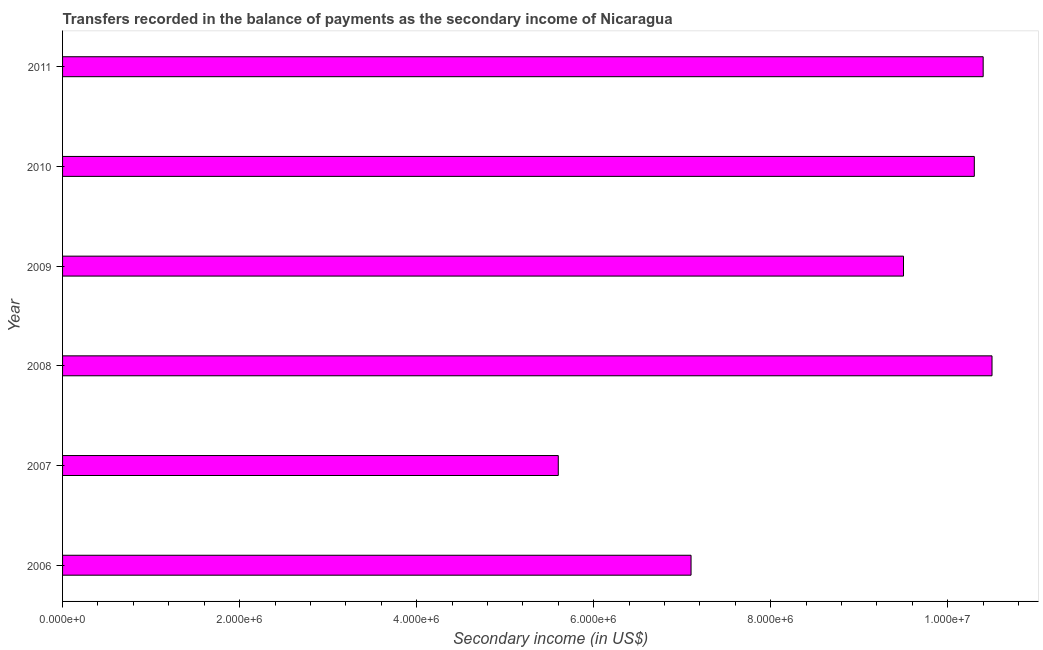Does the graph contain any zero values?
Ensure brevity in your answer.  No. Does the graph contain grids?
Provide a succinct answer. No. What is the title of the graph?
Offer a terse response. Transfers recorded in the balance of payments as the secondary income of Nicaragua. What is the label or title of the X-axis?
Offer a terse response. Secondary income (in US$). What is the label or title of the Y-axis?
Give a very brief answer. Year. What is the amount of secondary income in 2008?
Your response must be concise. 1.05e+07. Across all years, what is the maximum amount of secondary income?
Make the answer very short. 1.05e+07. Across all years, what is the minimum amount of secondary income?
Provide a short and direct response. 5.60e+06. In which year was the amount of secondary income maximum?
Keep it short and to the point. 2008. In which year was the amount of secondary income minimum?
Provide a short and direct response. 2007. What is the sum of the amount of secondary income?
Your response must be concise. 5.34e+07. What is the difference between the amount of secondary income in 2009 and 2011?
Give a very brief answer. -9.00e+05. What is the average amount of secondary income per year?
Offer a very short reply. 8.90e+06. What is the median amount of secondary income?
Give a very brief answer. 9.90e+06. What is the ratio of the amount of secondary income in 2008 to that in 2011?
Offer a very short reply. 1.01. What is the difference between the highest and the second highest amount of secondary income?
Keep it short and to the point. 1.00e+05. Is the sum of the amount of secondary income in 2007 and 2010 greater than the maximum amount of secondary income across all years?
Provide a short and direct response. Yes. What is the difference between the highest and the lowest amount of secondary income?
Your answer should be compact. 4.90e+06. In how many years, is the amount of secondary income greater than the average amount of secondary income taken over all years?
Provide a succinct answer. 4. What is the difference between two consecutive major ticks on the X-axis?
Provide a succinct answer. 2.00e+06. What is the Secondary income (in US$) in 2006?
Ensure brevity in your answer.  7.10e+06. What is the Secondary income (in US$) in 2007?
Make the answer very short. 5.60e+06. What is the Secondary income (in US$) of 2008?
Keep it short and to the point. 1.05e+07. What is the Secondary income (in US$) of 2009?
Your answer should be very brief. 9.50e+06. What is the Secondary income (in US$) of 2010?
Your answer should be very brief. 1.03e+07. What is the Secondary income (in US$) in 2011?
Ensure brevity in your answer.  1.04e+07. What is the difference between the Secondary income (in US$) in 2006 and 2007?
Offer a very short reply. 1.50e+06. What is the difference between the Secondary income (in US$) in 2006 and 2008?
Your answer should be very brief. -3.40e+06. What is the difference between the Secondary income (in US$) in 2006 and 2009?
Your answer should be compact. -2.40e+06. What is the difference between the Secondary income (in US$) in 2006 and 2010?
Provide a short and direct response. -3.20e+06. What is the difference between the Secondary income (in US$) in 2006 and 2011?
Keep it short and to the point. -3.30e+06. What is the difference between the Secondary income (in US$) in 2007 and 2008?
Provide a succinct answer. -4.90e+06. What is the difference between the Secondary income (in US$) in 2007 and 2009?
Provide a short and direct response. -3.90e+06. What is the difference between the Secondary income (in US$) in 2007 and 2010?
Your answer should be compact. -4.70e+06. What is the difference between the Secondary income (in US$) in 2007 and 2011?
Provide a succinct answer. -4.80e+06. What is the difference between the Secondary income (in US$) in 2008 and 2009?
Make the answer very short. 1.00e+06. What is the difference between the Secondary income (in US$) in 2008 and 2010?
Your answer should be very brief. 2.00e+05. What is the difference between the Secondary income (in US$) in 2008 and 2011?
Your response must be concise. 1.00e+05. What is the difference between the Secondary income (in US$) in 2009 and 2010?
Offer a very short reply. -8.00e+05. What is the difference between the Secondary income (in US$) in 2009 and 2011?
Make the answer very short. -9.00e+05. What is the difference between the Secondary income (in US$) in 2010 and 2011?
Offer a very short reply. -1.00e+05. What is the ratio of the Secondary income (in US$) in 2006 to that in 2007?
Ensure brevity in your answer.  1.27. What is the ratio of the Secondary income (in US$) in 2006 to that in 2008?
Provide a short and direct response. 0.68. What is the ratio of the Secondary income (in US$) in 2006 to that in 2009?
Give a very brief answer. 0.75. What is the ratio of the Secondary income (in US$) in 2006 to that in 2010?
Give a very brief answer. 0.69. What is the ratio of the Secondary income (in US$) in 2006 to that in 2011?
Give a very brief answer. 0.68. What is the ratio of the Secondary income (in US$) in 2007 to that in 2008?
Your answer should be compact. 0.53. What is the ratio of the Secondary income (in US$) in 2007 to that in 2009?
Ensure brevity in your answer.  0.59. What is the ratio of the Secondary income (in US$) in 2007 to that in 2010?
Keep it short and to the point. 0.54. What is the ratio of the Secondary income (in US$) in 2007 to that in 2011?
Offer a terse response. 0.54. What is the ratio of the Secondary income (in US$) in 2008 to that in 2009?
Offer a terse response. 1.1. What is the ratio of the Secondary income (in US$) in 2009 to that in 2010?
Your answer should be compact. 0.92. What is the ratio of the Secondary income (in US$) in 2009 to that in 2011?
Offer a very short reply. 0.91. 